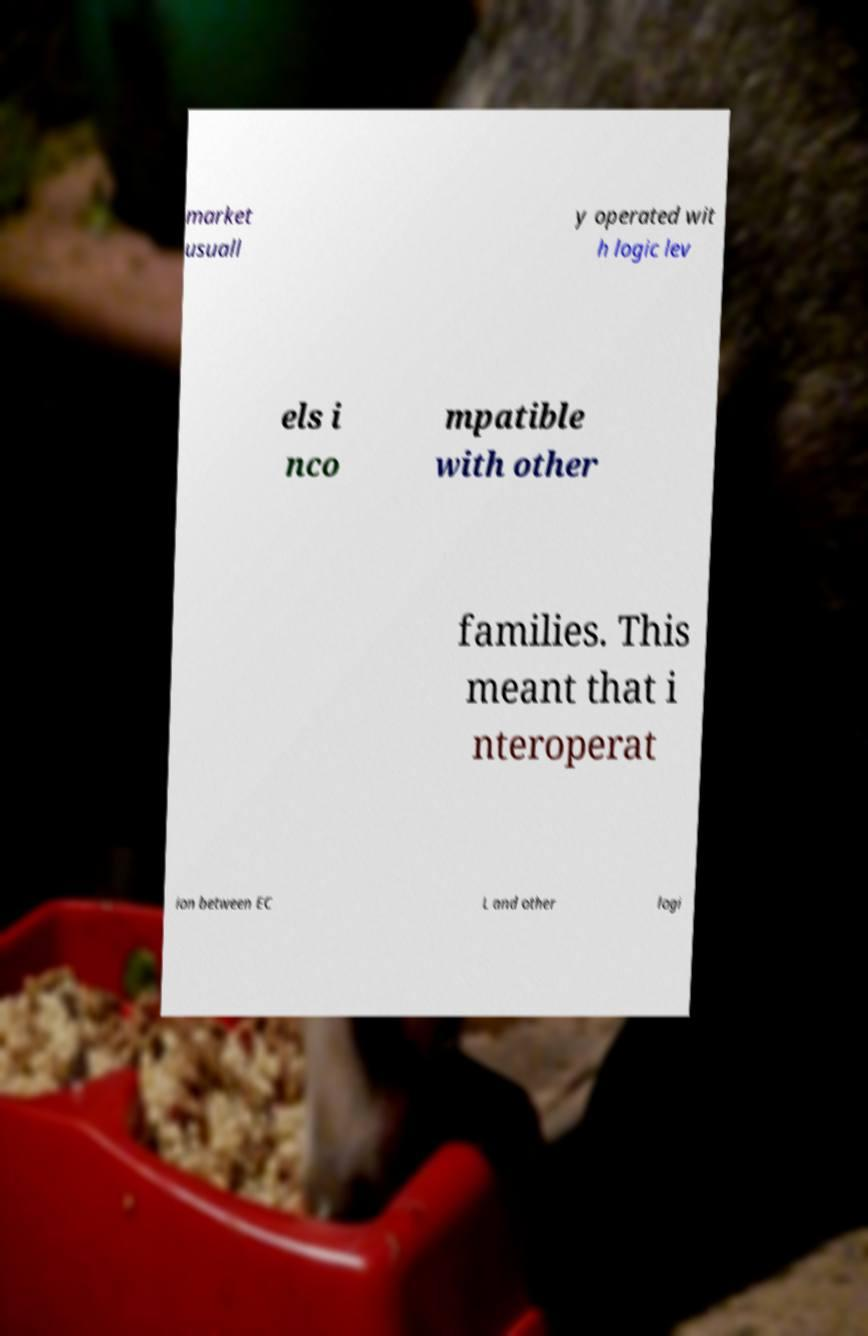I need the written content from this picture converted into text. Can you do that? market usuall y operated wit h logic lev els i nco mpatible with other families. This meant that i nteroperat ion between EC L and other logi 